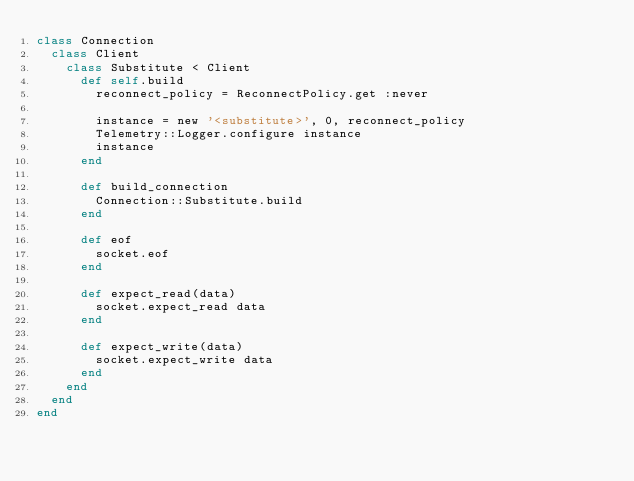<code> <loc_0><loc_0><loc_500><loc_500><_Ruby_>class Connection
  class Client
    class Substitute < Client
      def self.build
        reconnect_policy = ReconnectPolicy.get :never

        instance = new '<substitute>', 0, reconnect_policy
        Telemetry::Logger.configure instance
        instance
      end

      def build_connection
        Connection::Substitute.build
      end

      def eof
        socket.eof
      end

      def expect_read(data)
        socket.expect_read data
      end

      def expect_write(data)
        socket.expect_write data
      end
    end
  end
end
</code> 